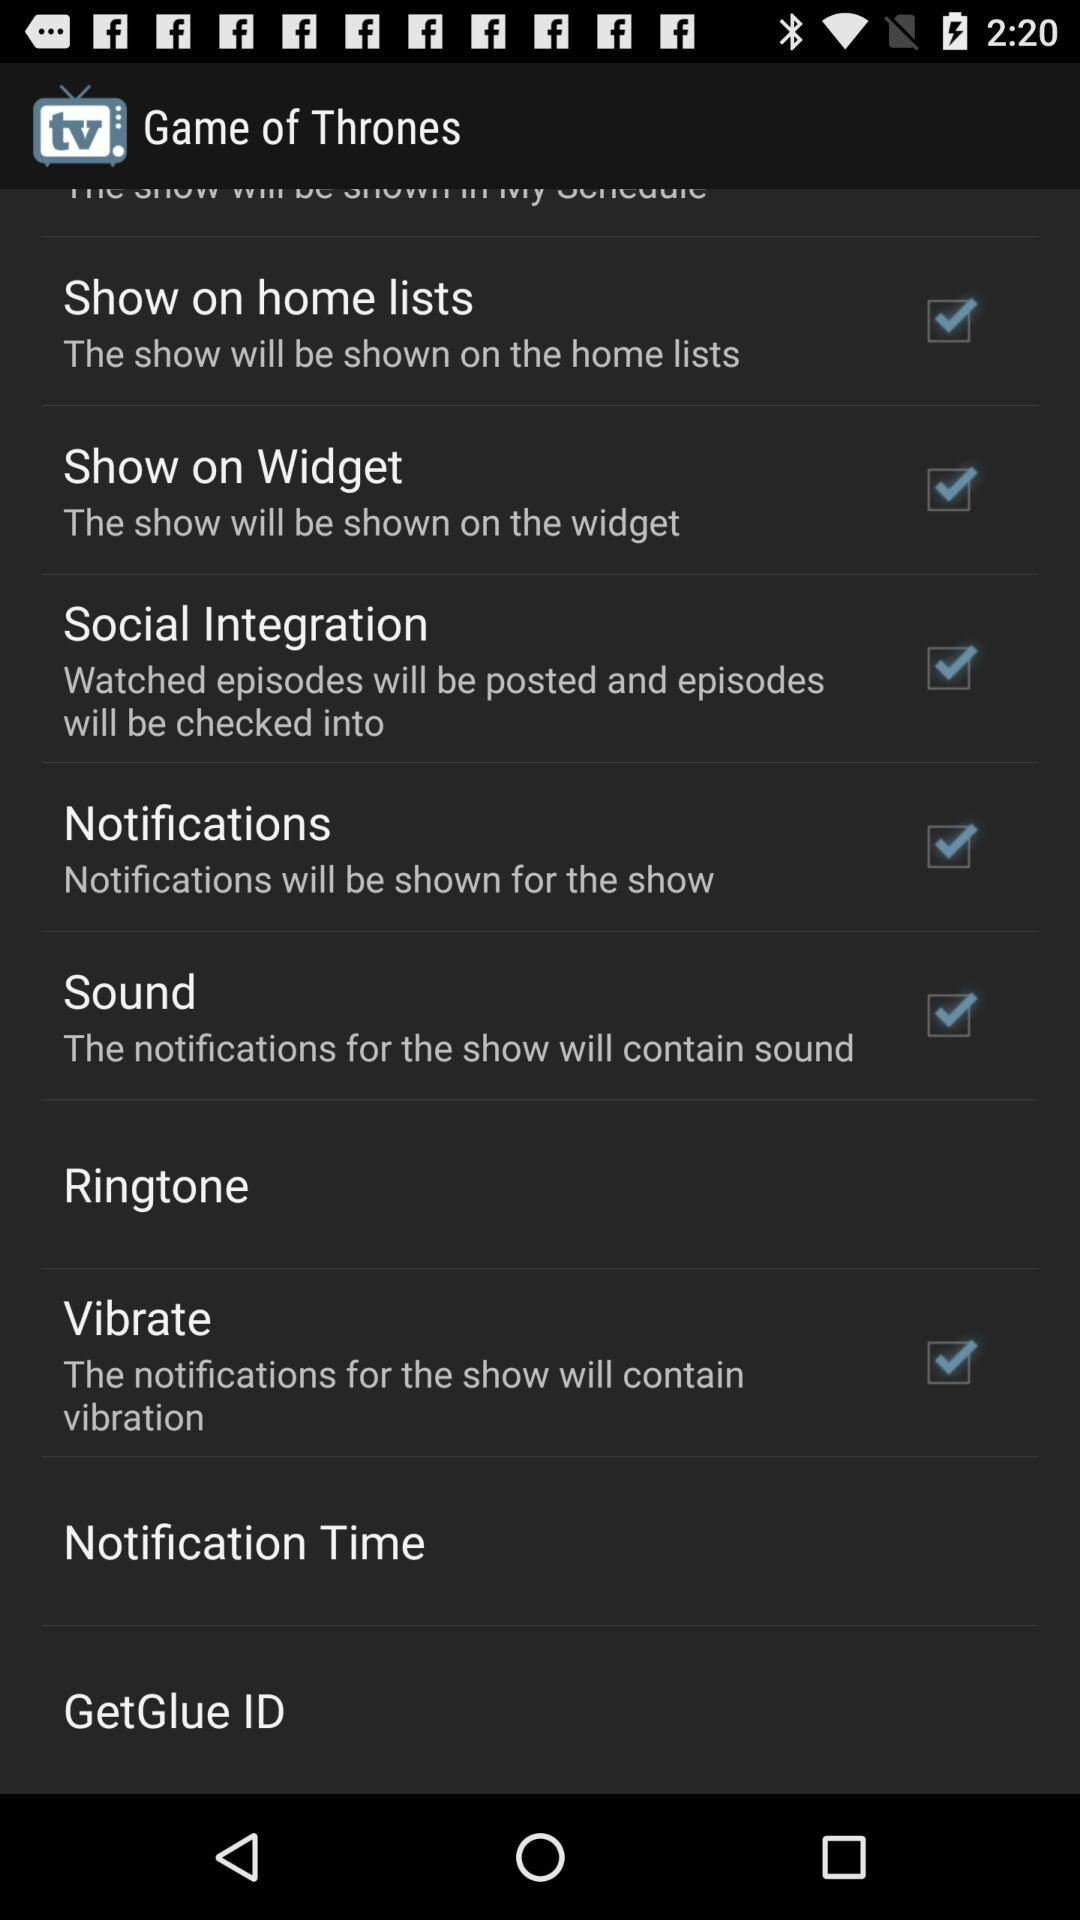What is the selected ringtone?
When the provided information is insufficient, respond with <no answer>. <no answer> 